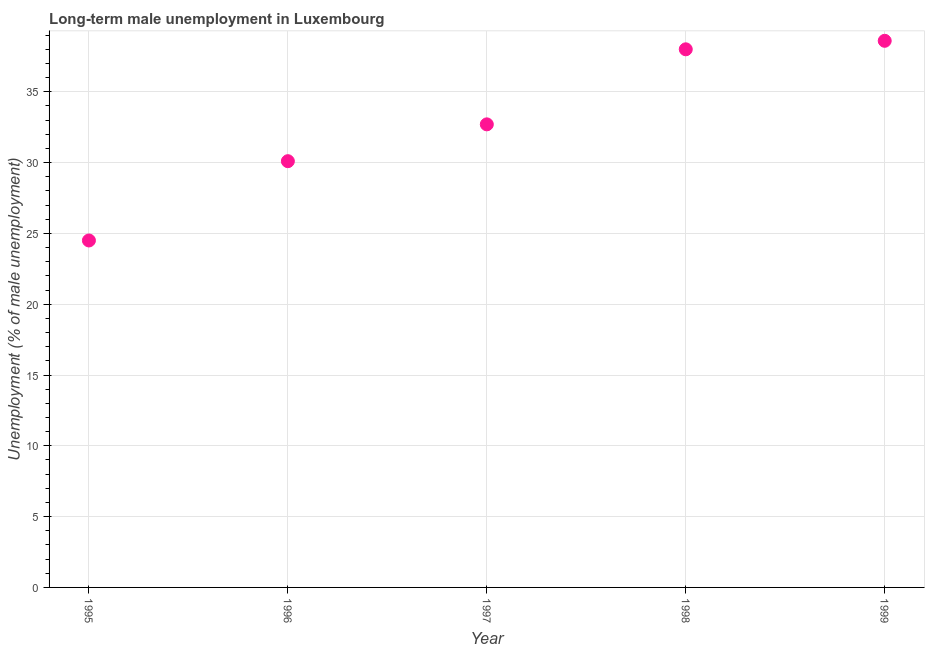Across all years, what is the maximum long-term male unemployment?
Keep it short and to the point. 38.6. In which year was the long-term male unemployment maximum?
Give a very brief answer. 1999. In which year was the long-term male unemployment minimum?
Ensure brevity in your answer.  1995. What is the sum of the long-term male unemployment?
Make the answer very short. 163.9. What is the difference between the long-term male unemployment in 1998 and 1999?
Give a very brief answer. -0.6. What is the average long-term male unemployment per year?
Offer a terse response. 32.78. What is the median long-term male unemployment?
Offer a terse response. 32.7. In how many years, is the long-term male unemployment greater than 13 %?
Keep it short and to the point. 5. What is the ratio of the long-term male unemployment in 1997 to that in 1999?
Give a very brief answer. 0.85. Is the long-term male unemployment in 1996 less than that in 1997?
Your answer should be compact. Yes. Is the difference between the long-term male unemployment in 1996 and 1997 greater than the difference between any two years?
Provide a short and direct response. No. What is the difference between the highest and the second highest long-term male unemployment?
Your response must be concise. 0.6. Is the sum of the long-term male unemployment in 1995 and 1998 greater than the maximum long-term male unemployment across all years?
Your answer should be very brief. Yes. What is the difference between the highest and the lowest long-term male unemployment?
Offer a terse response. 14.1. How many years are there in the graph?
Keep it short and to the point. 5. Are the values on the major ticks of Y-axis written in scientific E-notation?
Make the answer very short. No. Does the graph contain grids?
Provide a succinct answer. Yes. What is the title of the graph?
Make the answer very short. Long-term male unemployment in Luxembourg. What is the label or title of the Y-axis?
Provide a succinct answer. Unemployment (% of male unemployment). What is the Unemployment (% of male unemployment) in 1995?
Your response must be concise. 24.5. What is the Unemployment (% of male unemployment) in 1996?
Offer a terse response. 30.1. What is the Unemployment (% of male unemployment) in 1997?
Your answer should be very brief. 32.7. What is the Unemployment (% of male unemployment) in 1999?
Keep it short and to the point. 38.6. What is the difference between the Unemployment (% of male unemployment) in 1995 and 1997?
Your answer should be very brief. -8.2. What is the difference between the Unemployment (% of male unemployment) in 1995 and 1998?
Make the answer very short. -13.5. What is the difference between the Unemployment (% of male unemployment) in 1995 and 1999?
Offer a terse response. -14.1. What is the difference between the Unemployment (% of male unemployment) in 1997 and 1999?
Your answer should be very brief. -5.9. What is the ratio of the Unemployment (% of male unemployment) in 1995 to that in 1996?
Your answer should be compact. 0.81. What is the ratio of the Unemployment (% of male unemployment) in 1995 to that in 1997?
Keep it short and to the point. 0.75. What is the ratio of the Unemployment (% of male unemployment) in 1995 to that in 1998?
Your response must be concise. 0.65. What is the ratio of the Unemployment (% of male unemployment) in 1995 to that in 1999?
Your answer should be very brief. 0.64. What is the ratio of the Unemployment (% of male unemployment) in 1996 to that in 1997?
Make the answer very short. 0.92. What is the ratio of the Unemployment (% of male unemployment) in 1996 to that in 1998?
Provide a short and direct response. 0.79. What is the ratio of the Unemployment (% of male unemployment) in 1996 to that in 1999?
Offer a very short reply. 0.78. What is the ratio of the Unemployment (% of male unemployment) in 1997 to that in 1998?
Provide a short and direct response. 0.86. What is the ratio of the Unemployment (% of male unemployment) in 1997 to that in 1999?
Keep it short and to the point. 0.85. What is the ratio of the Unemployment (% of male unemployment) in 1998 to that in 1999?
Keep it short and to the point. 0.98. 